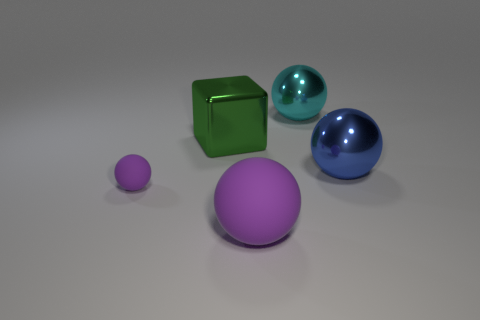What size is the metal ball on the left side of the blue metallic thing?
Provide a short and direct response. Large. Is the number of large metal spheres in front of the large green metallic thing greater than the number of big green blocks?
Provide a short and direct response. No. The big purple object is what shape?
Keep it short and to the point. Sphere. There is a large thing on the right side of the cyan metallic ball; is it the same color as the matte ball that is to the left of the green shiny cube?
Your response must be concise. No. Does the tiny matte object have the same shape as the blue thing?
Make the answer very short. Yes. Is there any other thing that has the same shape as the tiny purple thing?
Offer a terse response. Yes. Is the purple ball left of the big rubber ball made of the same material as the block?
Your answer should be compact. No. What is the shape of the shiny object that is in front of the big cyan sphere and behind the blue metallic sphere?
Provide a short and direct response. Cube. Is there a blue metal object that is left of the metal thing that is to the left of the large purple matte object?
Ensure brevity in your answer.  No. How many other things are there of the same material as the tiny purple ball?
Keep it short and to the point. 1. 